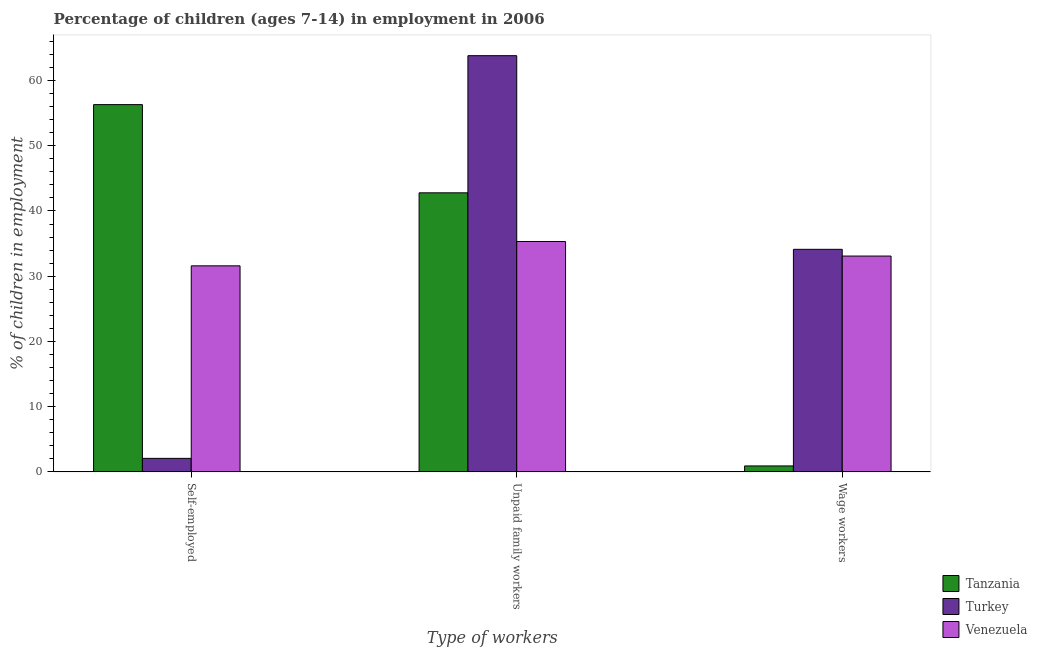How many different coloured bars are there?
Offer a terse response. 3. How many groups of bars are there?
Offer a terse response. 3. Are the number of bars on each tick of the X-axis equal?
Make the answer very short. Yes. How many bars are there on the 1st tick from the right?
Offer a terse response. 3. What is the label of the 1st group of bars from the left?
Your answer should be compact. Self-employed. Across all countries, what is the maximum percentage of self employed children?
Provide a succinct answer. 56.3. Across all countries, what is the minimum percentage of self employed children?
Keep it short and to the point. 2.08. In which country was the percentage of children employed as wage workers minimum?
Give a very brief answer. Tanzania. What is the total percentage of children employed as wage workers in the graph?
Keep it short and to the point. 68.13. What is the difference between the percentage of children employed as unpaid family workers in Venezuela and that in Turkey?
Your response must be concise. -28.48. What is the difference between the percentage of children employed as unpaid family workers in Turkey and the percentage of self employed children in Venezuela?
Give a very brief answer. 32.21. What is the average percentage of self employed children per country?
Your answer should be compact. 29.99. What is the difference between the percentage of children employed as wage workers and percentage of self employed children in Tanzania?
Your response must be concise. -55.38. What is the ratio of the percentage of self employed children in Venezuela to that in Tanzania?
Keep it short and to the point. 0.56. Is the difference between the percentage of self employed children in Venezuela and Tanzania greater than the difference between the percentage of children employed as unpaid family workers in Venezuela and Tanzania?
Give a very brief answer. No. What is the difference between the highest and the second highest percentage of children employed as unpaid family workers?
Provide a succinct answer. 21.02. What is the difference between the highest and the lowest percentage of children employed as unpaid family workers?
Give a very brief answer. 28.48. In how many countries, is the percentage of children employed as unpaid family workers greater than the average percentage of children employed as unpaid family workers taken over all countries?
Provide a succinct answer. 1. What does the 1st bar from the left in Unpaid family workers represents?
Offer a terse response. Tanzania. What does the 2nd bar from the right in Wage workers represents?
Provide a short and direct response. Turkey. How many bars are there?
Provide a succinct answer. 9. Does the graph contain any zero values?
Provide a short and direct response. No. Does the graph contain grids?
Your response must be concise. No. Where does the legend appear in the graph?
Provide a succinct answer. Bottom right. How many legend labels are there?
Your answer should be compact. 3. What is the title of the graph?
Keep it short and to the point. Percentage of children (ages 7-14) in employment in 2006. What is the label or title of the X-axis?
Make the answer very short. Type of workers. What is the label or title of the Y-axis?
Give a very brief answer. % of children in employment. What is the % of children in employment of Tanzania in Self-employed?
Make the answer very short. 56.3. What is the % of children in employment in Turkey in Self-employed?
Your answer should be very brief. 2.08. What is the % of children in employment in Venezuela in Self-employed?
Offer a terse response. 31.59. What is the % of children in employment in Tanzania in Unpaid family workers?
Provide a succinct answer. 42.78. What is the % of children in employment of Turkey in Unpaid family workers?
Offer a very short reply. 63.8. What is the % of children in employment in Venezuela in Unpaid family workers?
Give a very brief answer. 35.32. What is the % of children in employment in Tanzania in Wage workers?
Make the answer very short. 0.92. What is the % of children in employment of Turkey in Wage workers?
Make the answer very short. 34.12. What is the % of children in employment in Venezuela in Wage workers?
Keep it short and to the point. 33.09. Across all Type of workers, what is the maximum % of children in employment in Tanzania?
Your answer should be very brief. 56.3. Across all Type of workers, what is the maximum % of children in employment of Turkey?
Your answer should be compact. 63.8. Across all Type of workers, what is the maximum % of children in employment of Venezuela?
Keep it short and to the point. 35.32. Across all Type of workers, what is the minimum % of children in employment of Tanzania?
Ensure brevity in your answer.  0.92. Across all Type of workers, what is the minimum % of children in employment of Turkey?
Provide a short and direct response. 2.08. Across all Type of workers, what is the minimum % of children in employment in Venezuela?
Provide a short and direct response. 31.59. What is the total % of children in employment of Turkey in the graph?
Your answer should be compact. 100. What is the total % of children in employment of Venezuela in the graph?
Offer a terse response. 100. What is the difference between the % of children in employment in Tanzania in Self-employed and that in Unpaid family workers?
Your answer should be very brief. 13.52. What is the difference between the % of children in employment in Turkey in Self-employed and that in Unpaid family workers?
Offer a very short reply. -61.72. What is the difference between the % of children in employment in Venezuela in Self-employed and that in Unpaid family workers?
Your response must be concise. -3.73. What is the difference between the % of children in employment of Tanzania in Self-employed and that in Wage workers?
Your response must be concise. 55.38. What is the difference between the % of children in employment of Turkey in Self-employed and that in Wage workers?
Your answer should be very brief. -32.04. What is the difference between the % of children in employment of Venezuela in Self-employed and that in Wage workers?
Keep it short and to the point. -1.5. What is the difference between the % of children in employment in Tanzania in Unpaid family workers and that in Wage workers?
Provide a succinct answer. 41.86. What is the difference between the % of children in employment in Turkey in Unpaid family workers and that in Wage workers?
Make the answer very short. 29.68. What is the difference between the % of children in employment in Venezuela in Unpaid family workers and that in Wage workers?
Provide a succinct answer. 2.23. What is the difference between the % of children in employment in Tanzania in Self-employed and the % of children in employment in Venezuela in Unpaid family workers?
Make the answer very short. 20.98. What is the difference between the % of children in employment of Turkey in Self-employed and the % of children in employment of Venezuela in Unpaid family workers?
Your answer should be very brief. -33.24. What is the difference between the % of children in employment in Tanzania in Self-employed and the % of children in employment in Turkey in Wage workers?
Your answer should be compact. 22.18. What is the difference between the % of children in employment of Tanzania in Self-employed and the % of children in employment of Venezuela in Wage workers?
Offer a terse response. 23.21. What is the difference between the % of children in employment in Turkey in Self-employed and the % of children in employment in Venezuela in Wage workers?
Offer a terse response. -31.01. What is the difference between the % of children in employment of Tanzania in Unpaid family workers and the % of children in employment of Turkey in Wage workers?
Ensure brevity in your answer.  8.66. What is the difference between the % of children in employment in Tanzania in Unpaid family workers and the % of children in employment in Venezuela in Wage workers?
Provide a short and direct response. 9.69. What is the difference between the % of children in employment in Turkey in Unpaid family workers and the % of children in employment in Venezuela in Wage workers?
Offer a very short reply. 30.71. What is the average % of children in employment in Tanzania per Type of workers?
Make the answer very short. 33.33. What is the average % of children in employment of Turkey per Type of workers?
Provide a short and direct response. 33.33. What is the average % of children in employment of Venezuela per Type of workers?
Ensure brevity in your answer.  33.33. What is the difference between the % of children in employment of Tanzania and % of children in employment of Turkey in Self-employed?
Your response must be concise. 54.22. What is the difference between the % of children in employment in Tanzania and % of children in employment in Venezuela in Self-employed?
Ensure brevity in your answer.  24.71. What is the difference between the % of children in employment in Turkey and % of children in employment in Venezuela in Self-employed?
Offer a very short reply. -29.51. What is the difference between the % of children in employment in Tanzania and % of children in employment in Turkey in Unpaid family workers?
Give a very brief answer. -21.02. What is the difference between the % of children in employment in Tanzania and % of children in employment in Venezuela in Unpaid family workers?
Give a very brief answer. 7.46. What is the difference between the % of children in employment of Turkey and % of children in employment of Venezuela in Unpaid family workers?
Make the answer very short. 28.48. What is the difference between the % of children in employment of Tanzania and % of children in employment of Turkey in Wage workers?
Your response must be concise. -33.2. What is the difference between the % of children in employment in Tanzania and % of children in employment in Venezuela in Wage workers?
Make the answer very short. -32.17. What is the ratio of the % of children in employment in Tanzania in Self-employed to that in Unpaid family workers?
Provide a succinct answer. 1.32. What is the ratio of the % of children in employment in Turkey in Self-employed to that in Unpaid family workers?
Provide a short and direct response. 0.03. What is the ratio of the % of children in employment of Venezuela in Self-employed to that in Unpaid family workers?
Your answer should be very brief. 0.89. What is the ratio of the % of children in employment of Tanzania in Self-employed to that in Wage workers?
Offer a terse response. 61.2. What is the ratio of the % of children in employment of Turkey in Self-employed to that in Wage workers?
Keep it short and to the point. 0.06. What is the ratio of the % of children in employment of Venezuela in Self-employed to that in Wage workers?
Provide a short and direct response. 0.95. What is the ratio of the % of children in employment of Tanzania in Unpaid family workers to that in Wage workers?
Your response must be concise. 46.5. What is the ratio of the % of children in employment of Turkey in Unpaid family workers to that in Wage workers?
Offer a very short reply. 1.87. What is the ratio of the % of children in employment in Venezuela in Unpaid family workers to that in Wage workers?
Make the answer very short. 1.07. What is the difference between the highest and the second highest % of children in employment in Tanzania?
Ensure brevity in your answer.  13.52. What is the difference between the highest and the second highest % of children in employment in Turkey?
Ensure brevity in your answer.  29.68. What is the difference between the highest and the second highest % of children in employment of Venezuela?
Keep it short and to the point. 2.23. What is the difference between the highest and the lowest % of children in employment of Tanzania?
Keep it short and to the point. 55.38. What is the difference between the highest and the lowest % of children in employment of Turkey?
Keep it short and to the point. 61.72. What is the difference between the highest and the lowest % of children in employment in Venezuela?
Provide a short and direct response. 3.73. 